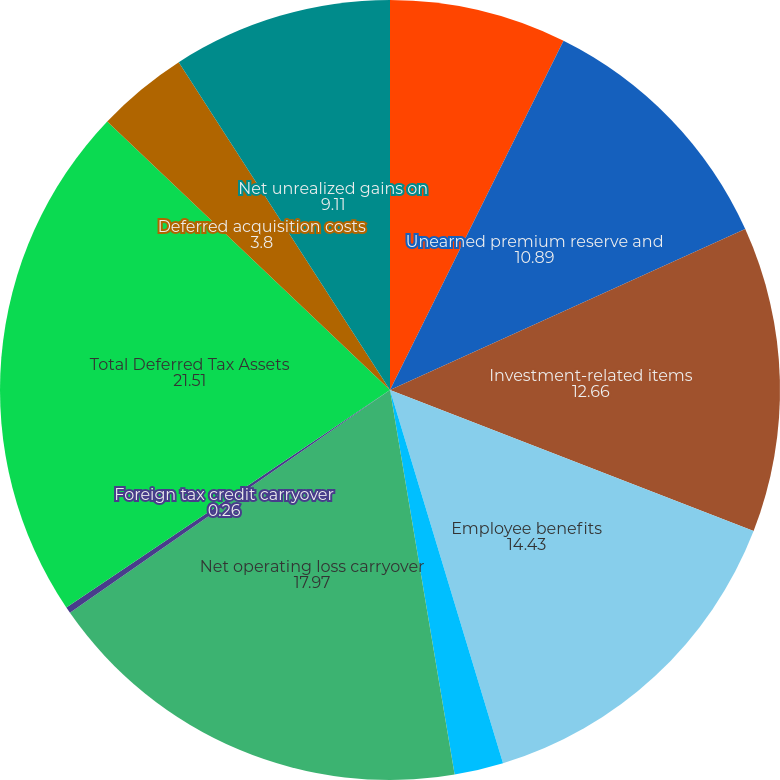<chart> <loc_0><loc_0><loc_500><loc_500><pie_chart><fcel>Loss reserves and tax discount<fcel>Unearned premium reserve and<fcel>Investment-related items<fcel>Employee benefits<fcel>General business credit<fcel>Net operating loss carryover<fcel>Foreign tax credit carryover<fcel>Total Deferred Tax Assets<fcel>Deferred acquisition costs<fcel>Net unrealized gains on<nl><fcel>7.34%<fcel>10.89%<fcel>12.66%<fcel>14.43%<fcel>2.03%<fcel>17.97%<fcel>0.26%<fcel>21.51%<fcel>3.8%<fcel>9.11%<nl></chart> 